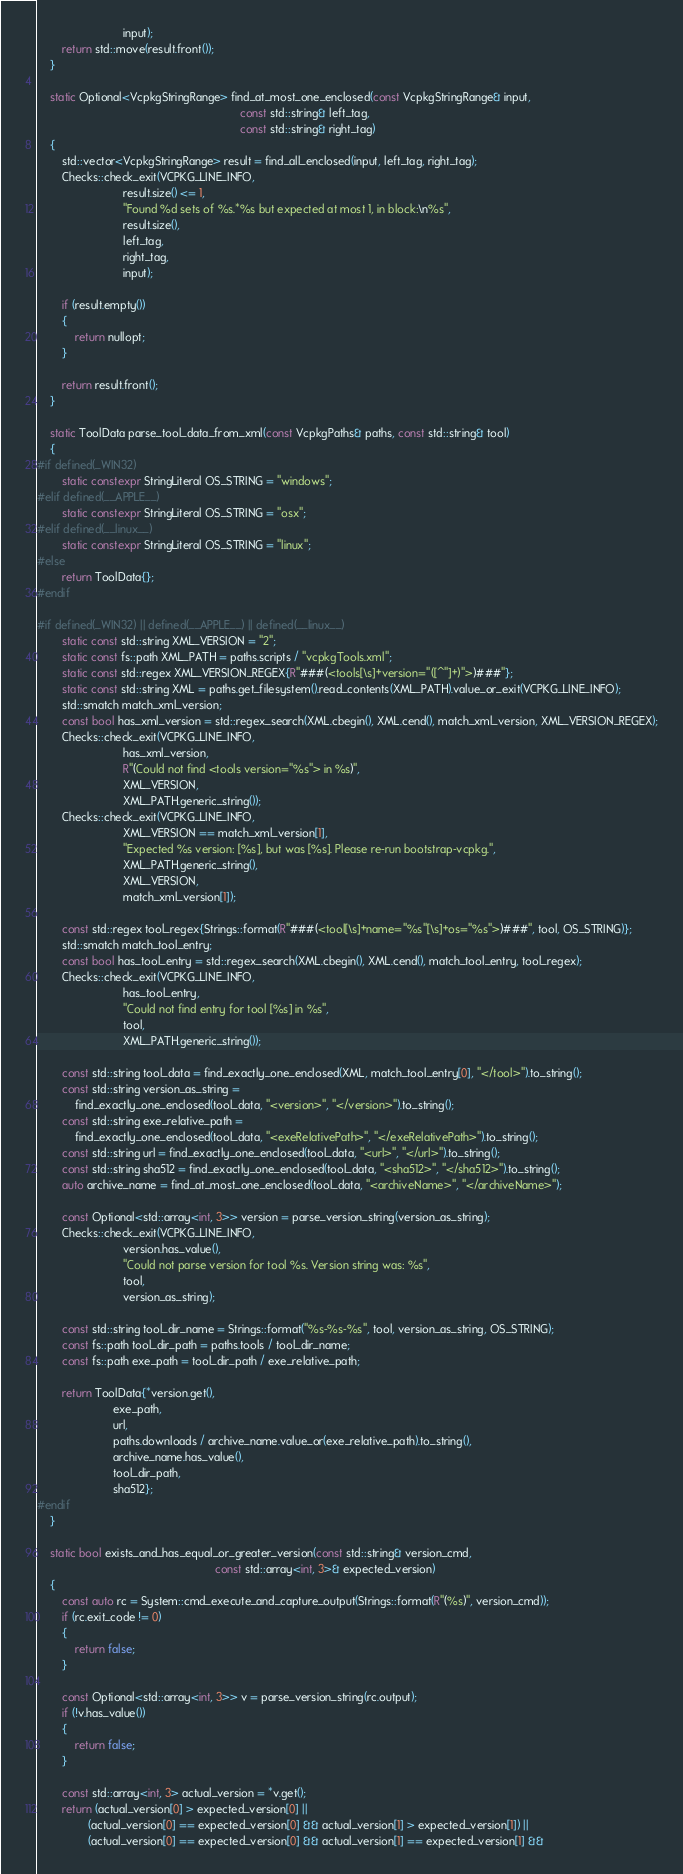<code> <loc_0><loc_0><loc_500><loc_500><_C++_>                           input);
        return std::move(result.front());
    }

    static Optional<VcpkgStringRange> find_at_most_one_enclosed(const VcpkgStringRange& input,
                                                                const std::string& left_tag,
                                                                const std::string& right_tag)
    {
        std::vector<VcpkgStringRange> result = find_all_enclosed(input, left_tag, right_tag);
        Checks::check_exit(VCPKG_LINE_INFO,
                           result.size() <= 1,
                           "Found %d sets of %s.*%s but expected at most 1, in block:\n%s",
                           result.size(),
                           left_tag,
                           right_tag,
                           input);

        if (result.empty())
        {
            return nullopt;
        }

        return result.front();
    }

    static ToolData parse_tool_data_from_xml(const VcpkgPaths& paths, const std::string& tool)
    {
#if defined(_WIN32)
        static constexpr StringLiteral OS_STRING = "windows";
#elif defined(__APPLE__)
        static constexpr StringLiteral OS_STRING = "osx";
#elif defined(__linux__)
        static constexpr StringLiteral OS_STRING = "linux";
#else
        return ToolData{};
#endif

#if defined(_WIN32) || defined(__APPLE__) || defined(__linux__)
        static const std::string XML_VERSION = "2";
        static const fs::path XML_PATH = paths.scripts / "vcpkgTools.xml";
        static const std::regex XML_VERSION_REGEX{R"###(<tools[\s]+version="([^"]+)">)###"};
        static const std::string XML = paths.get_filesystem().read_contents(XML_PATH).value_or_exit(VCPKG_LINE_INFO);
        std::smatch match_xml_version;
        const bool has_xml_version = std::regex_search(XML.cbegin(), XML.cend(), match_xml_version, XML_VERSION_REGEX);
        Checks::check_exit(VCPKG_LINE_INFO,
                           has_xml_version,
                           R"(Could not find <tools version="%s"> in %s)",
                           XML_VERSION,
                           XML_PATH.generic_string());
        Checks::check_exit(VCPKG_LINE_INFO,
                           XML_VERSION == match_xml_version[1],
                           "Expected %s version: [%s], but was [%s]. Please re-run bootstrap-vcpkg.",
                           XML_PATH.generic_string(),
                           XML_VERSION,
                           match_xml_version[1]);

        const std::regex tool_regex{Strings::format(R"###(<tool[\s]+name="%s"[\s]+os="%s">)###", tool, OS_STRING)};
        std::smatch match_tool_entry;
        const bool has_tool_entry = std::regex_search(XML.cbegin(), XML.cend(), match_tool_entry, tool_regex);
        Checks::check_exit(VCPKG_LINE_INFO,
                           has_tool_entry,
                           "Could not find entry for tool [%s] in %s",
                           tool,
                           XML_PATH.generic_string());

        const std::string tool_data = find_exactly_one_enclosed(XML, match_tool_entry[0], "</tool>").to_string();
        const std::string version_as_string =
            find_exactly_one_enclosed(tool_data, "<version>", "</version>").to_string();
        const std::string exe_relative_path =
            find_exactly_one_enclosed(tool_data, "<exeRelativePath>", "</exeRelativePath>").to_string();
        const std::string url = find_exactly_one_enclosed(tool_data, "<url>", "</url>").to_string();
        const std::string sha512 = find_exactly_one_enclosed(tool_data, "<sha512>", "</sha512>").to_string();
        auto archive_name = find_at_most_one_enclosed(tool_data, "<archiveName>", "</archiveName>");

        const Optional<std::array<int, 3>> version = parse_version_string(version_as_string);
        Checks::check_exit(VCPKG_LINE_INFO,
                           version.has_value(),
                           "Could not parse version for tool %s. Version string was: %s",
                           tool,
                           version_as_string);

        const std::string tool_dir_name = Strings::format("%s-%s-%s", tool, version_as_string, OS_STRING);
        const fs::path tool_dir_path = paths.tools / tool_dir_name;
        const fs::path exe_path = tool_dir_path / exe_relative_path;

        return ToolData{*version.get(),
                        exe_path,
                        url,
                        paths.downloads / archive_name.value_or(exe_relative_path).to_string(),
                        archive_name.has_value(),
                        tool_dir_path,
                        sha512};
#endif
    }

    static bool exists_and_has_equal_or_greater_version(const std::string& version_cmd,
                                                        const std::array<int, 3>& expected_version)
    {
        const auto rc = System::cmd_execute_and_capture_output(Strings::format(R"(%s)", version_cmd));
        if (rc.exit_code != 0)
        {
            return false;
        }

        const Optional<std::array<int, 3>> v = parse_version_string(rc.output);
        if (!v.has_value())
        {
            return false;
        }

        const std::array<int, 3> actual_version = *v.get();
        return (actual_version[0] > expected_version[0] ||
                (actual_version[0] == expected_version[0] && actual_version[1] > expected_version[1]) ||
                (actual_version[0] == expected_version[0] && actual_version[1] == expected_version[1] &&</code> 